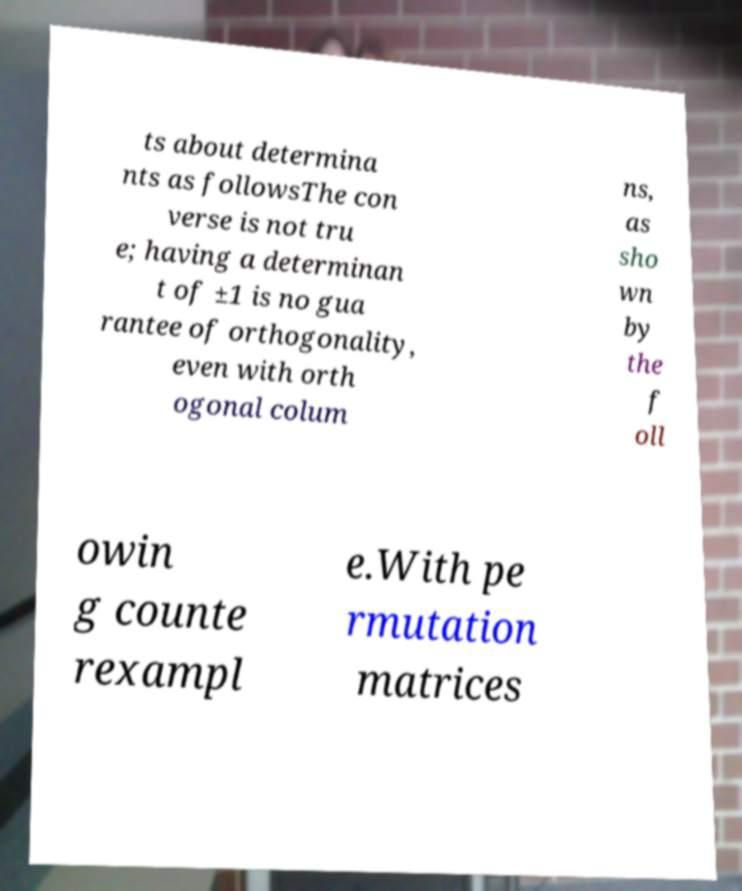Please identify and transcribe the text found in this image. ts about determina nts as followsThe con verse is not tru e; having a determinan t of ±1 is no gua rantee of orthogonality, even with orth ogonal colum ns, as sho wn by the f oll owin g counte rexampl e.With pe rmutation matrices 